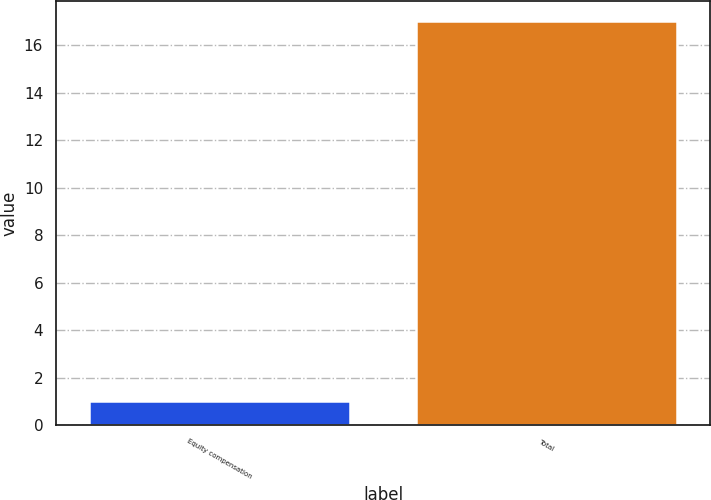Convert chart to OTSL. <chart><loc_0><loc_0><loc_500><loc_500><bar_chart><fcel>Equity compensation<fcel>Total<nl><fcel>1<fcel>17<nl></chart> 